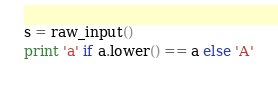Convert code to text. <code><loc_0><loc_0><loc_500><loc_500><_Python_>
s = raw_input()
print 'a' if a.lower() == a else 'A'</code> 